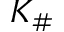<formula> <loc_0><loc_0><loc_500><loc_500>K _ { \# }</formula> 